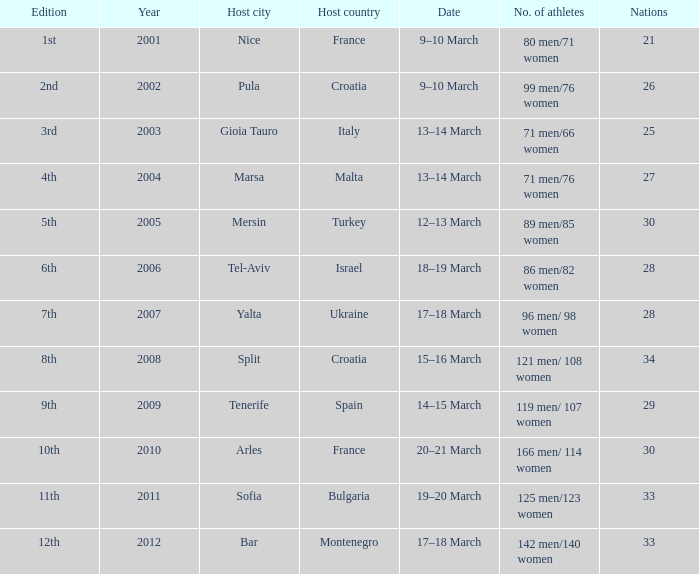What was the number of athletes in the host city of Nice? 80 men/71 women. 